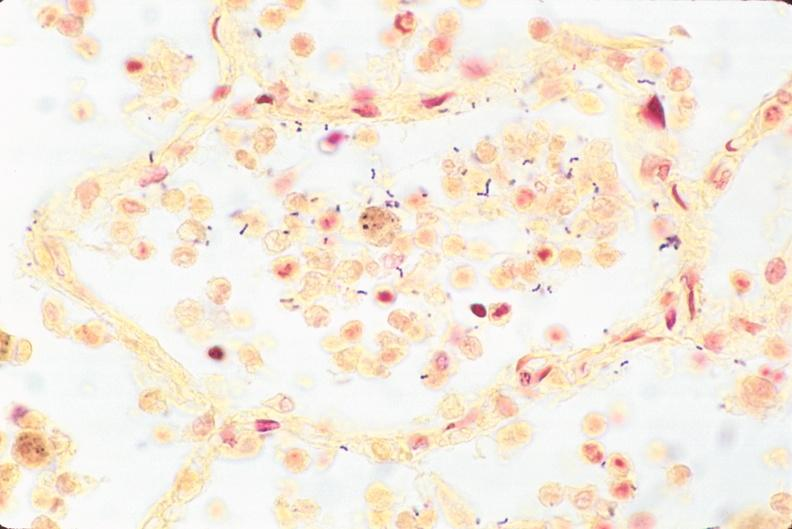what stain?
Answer the question using a single word or phrase. This image shows lung 